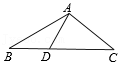What can you tell me about the properties of triangle ABC? Triangle ABC appears to be an isosceles triangle, meaning it has two sides of equal length, which in this case are AB and AC. Furthermore, the triangle possesses symmetry along the perpendicular bisector of the base, line segment AB. This symmetry implies that angles ADB and ADB are also equal. 